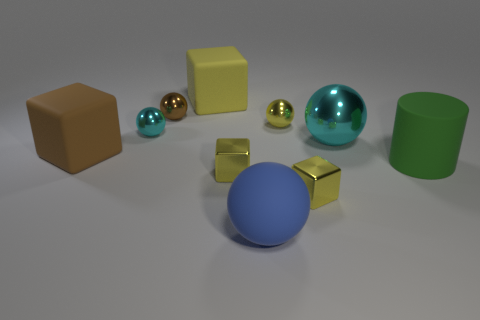There is a cyan object that is right of the small brown metallic ball; what shape is it?
Give a very brief answer. Sphere. The brown sphere that is the same material as the tiny yellow ball is what size?
Keep it short and to the point. Small. The metallic thing that is behind the large cyan metal ball and to the right of the brown shiny object has what shape?
Keep it short and to the point. Sphere. There is a small shiny ball in front of the yellow ball; is its color the same as the large metal sphere?
Provide a succinct answer. Yes. Do the large matte object behind the large brown object and the brown object that is behind the brown matte thing have the same shape?
Make the answer very short. No. There is a yellow cube behind the tiny brown sphere; what size is it?
Provide a succinct answer. Large. What is the size of the yellow shiny object to the right of the tiny ball that is to the right of the tiny brown ball?
Provide a short and direct response. Small. Is the number of large blue things greater than the number of blocks?
Give a very brief answer. No. Is the number of balls that are left of the large yellow rubber cube greater than the number of big brown rubber things that are on the right side of the large cyan metal object?
Your answer should be very brief. Yes. There is a matte thing that is left of the green thing and in front of the brown rubber block; what is its size?
Offer a very short reply. Large. 